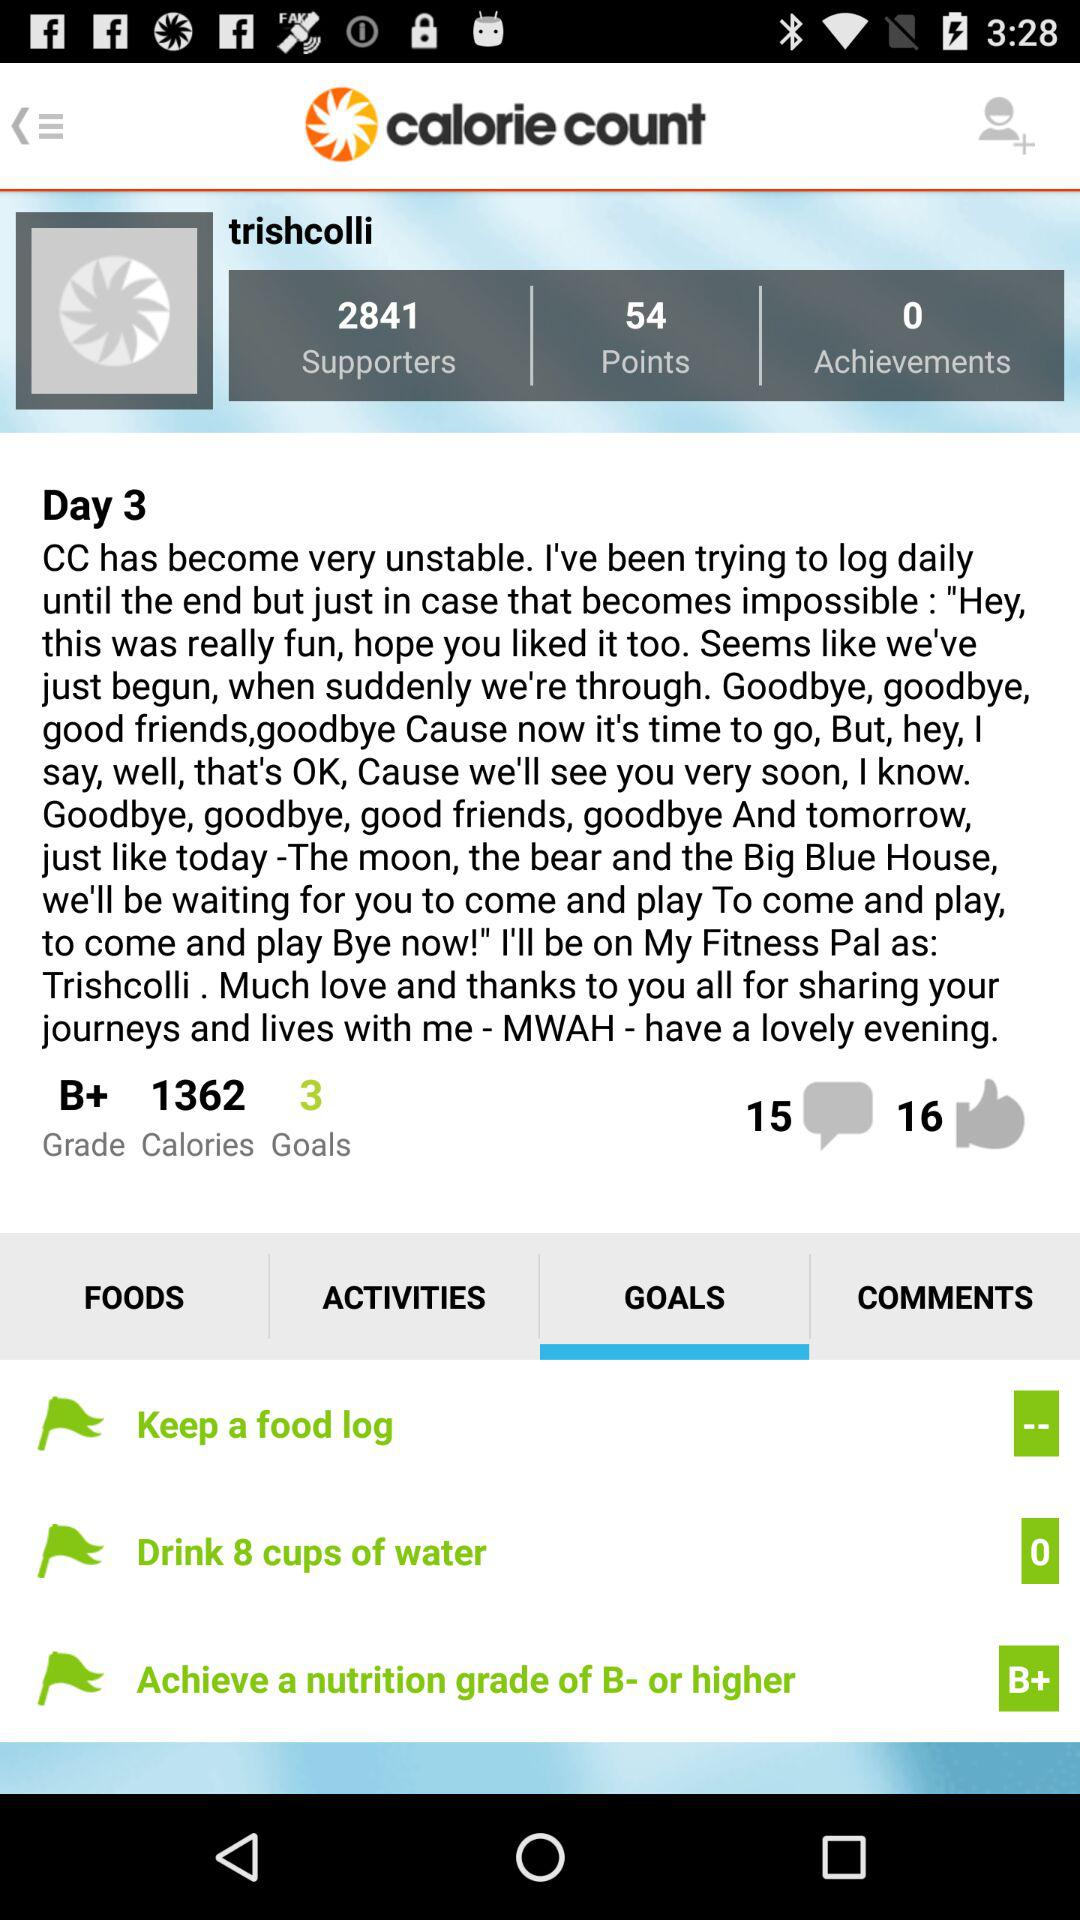How many goals does the user have?
Answer the question using a single word or phrase. 3 